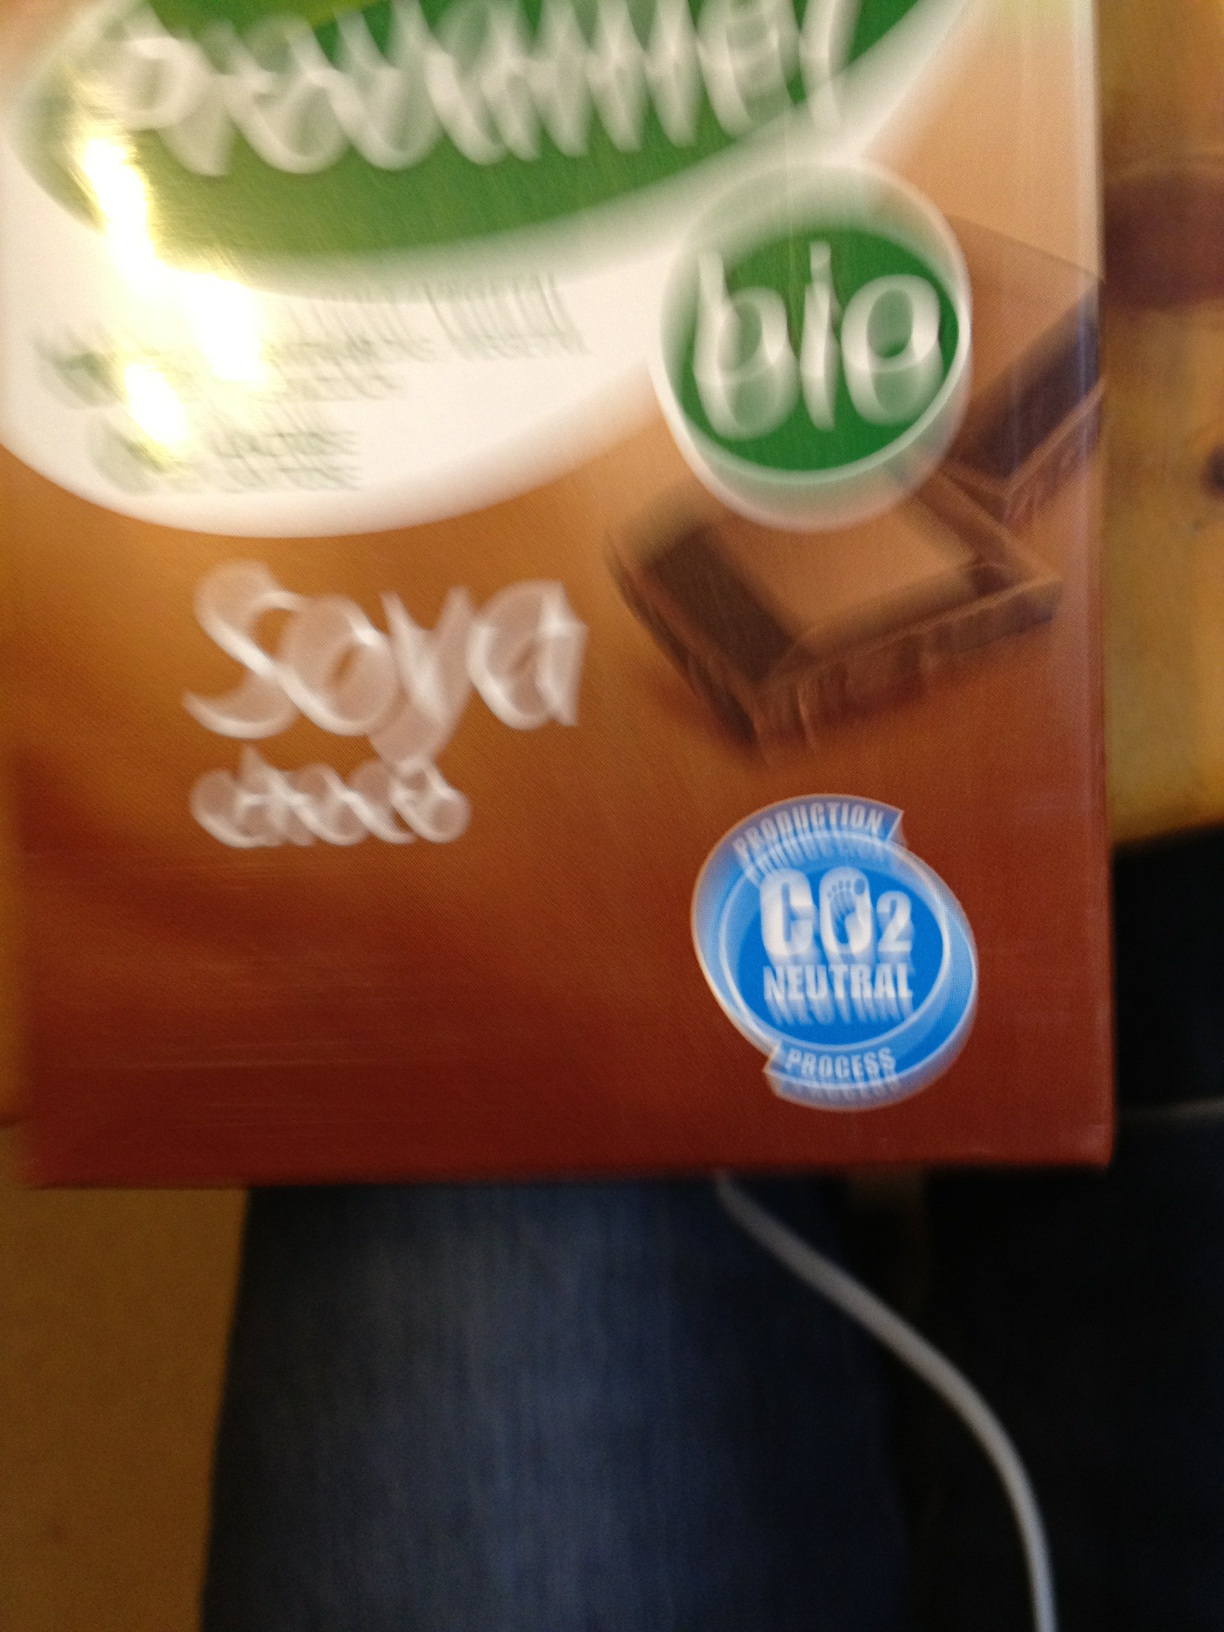In this photo, which is number one, soy cocoa or normal cocoa? Excuse me. Soy cocoa or normal soy? The image is unclear and the text label on the product that might provide clarification is blurred and barely legible. This makes it difficult to determine whether the product is soy cocoa or simply soy-based. For a precise answer, clearer visual quality or specific product information would be necessary. 